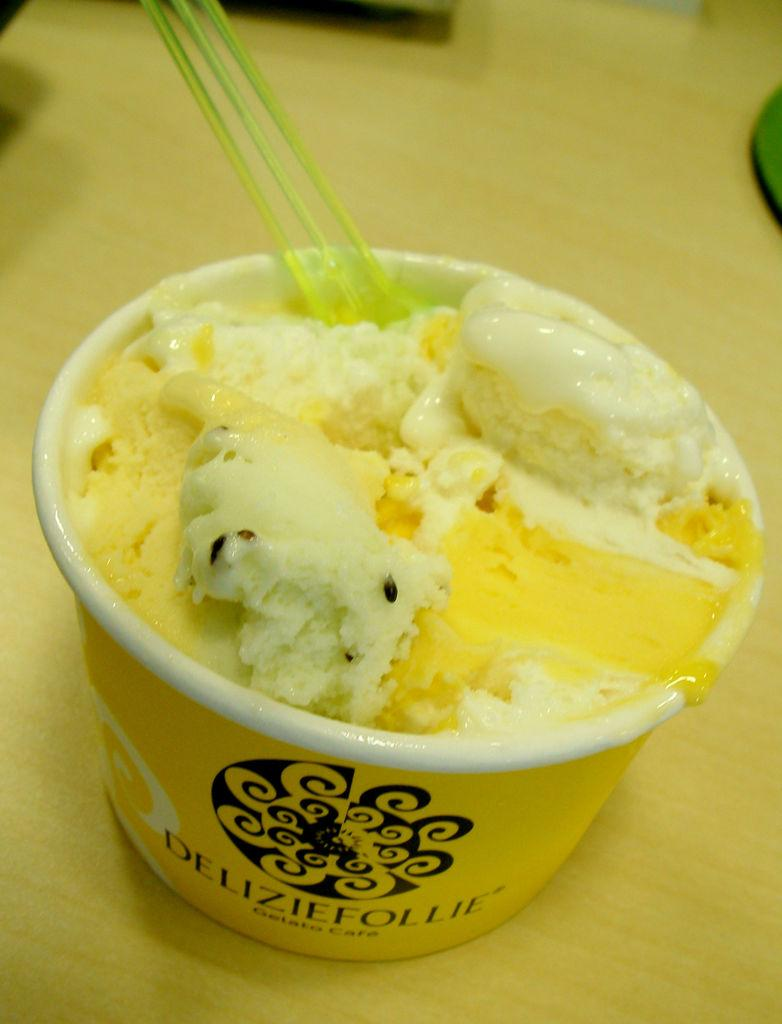What is the main subject of the image? The main subject of the image is an ice cream. What can be found in the cup in the image? There are spoons in a cup in the image. What is the location of the objects in the image? The objects are on a platform in the image. What type of gold object is present on the platform in the image? There is no gold object present on the platform in the image. 